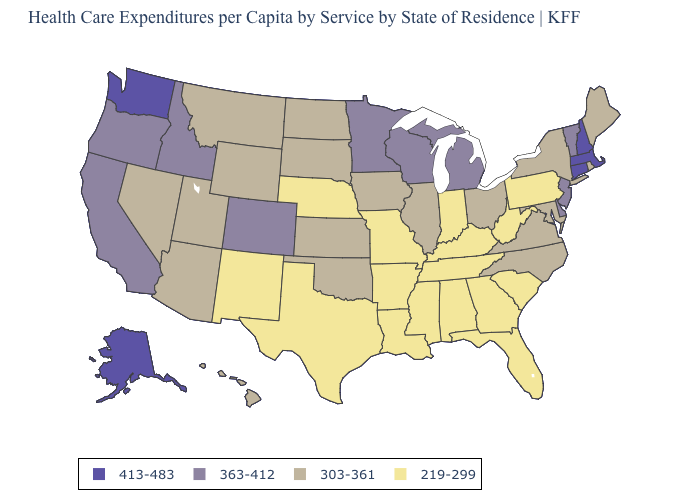Name the states that have a value in the range 413-483?
Give a very brief answer. Alaska, Connecticut, Massachusetts, New Hampshire, Washington. Name the states that have a value in the range 303-361?
Write a very short answer. Arizona, Hawaii, Illinois, Iowa, Kansas, Maine, Maryland, Montana, Nevada, New York, North Carolina, North Dakota, Ohio, Oklahoma, Rhode Island, South Dakota, Utah, Virginia, Wyoming. What is the value of Montana?
Answer briefly. 303-361. Name the states that have a value in the range 363-412?
Concise answer only. California, Colorado, Delaware, Idaho, Michigan, Minnesota, New Jersey, Oregon, Vermont, Wisconsin. What is the highest value in the USA?
Keep it brief. 413-483. What is the value of Maine?
Write a very short answer. 303-361. Which states have the highest value in the USA?
Short answer required. Alaska, Connecticut, Massachusetts, New Hampshire, Washington. What is the highest value in states that border Kansas?
Concise answer only. 363-412. How many symbols are there in the legend?
Be succinct. 4. Name the states that have a value in the range 219-299?
Give a very brief answer. Alabama, Arkansas, Florida, Georgia, Indiana, Kentucky, Louisiana, Mississippi, Missouri, Nebraska, New Mexico, Pennsylvania, South Carolina, Tennessee, Texas, West Virginia. Does Illinois have a lower value than Oklahoma?
Be succinct. No. Name the states that have a value in the range 219-299?
Write a very short answer. Alabama, Arkansas, Florida, Georgia, Indiana, Kentucky, Louisiana, Mississippi, Missouri, Nebraska, New Mexico, Pennsylvania, South Carolina, Tennessee, Texas, West Virginia. What is the value of California?
Keep it brief. 363-412. Name the states that have a value in the range 363-412?
Concise answer only. California, Colorado, Delaware, Idaho, Michigan, Minnesota, New Jersey, Oregon, Vermont, Wisconsin. What is the value of Arizona?
Answer briefly. 303-361. 